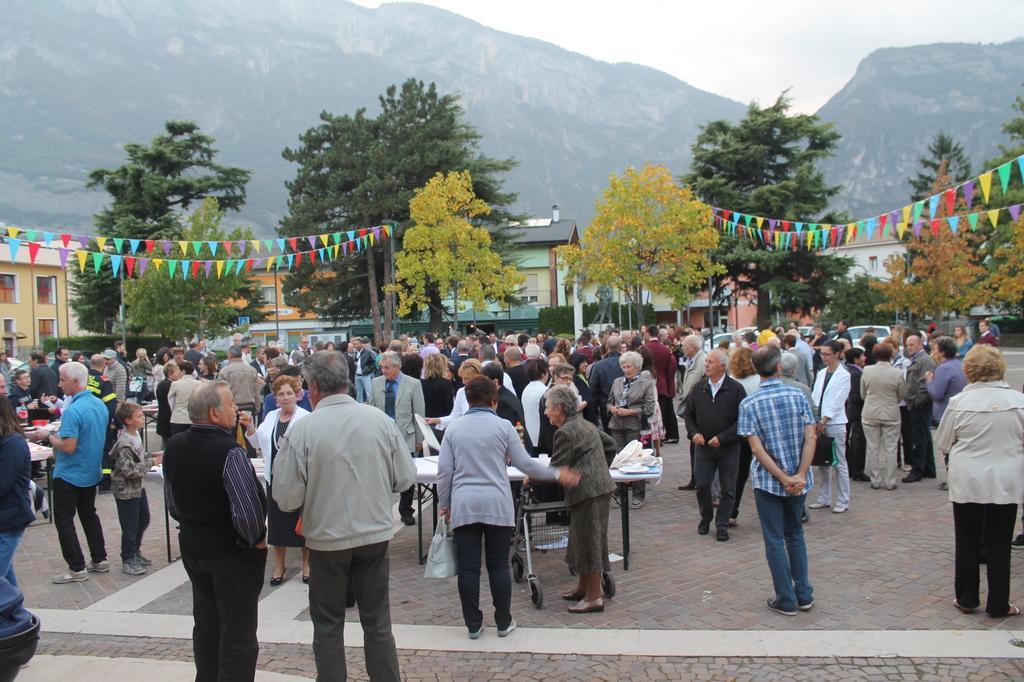Please provide a concise description of this image. In this image, we can see a group of people, tables are on the path. Background we can see few houses, trees, vehicles, poles, paper crafts, hills and sky. In this image, we can see few people are holding some objects. 